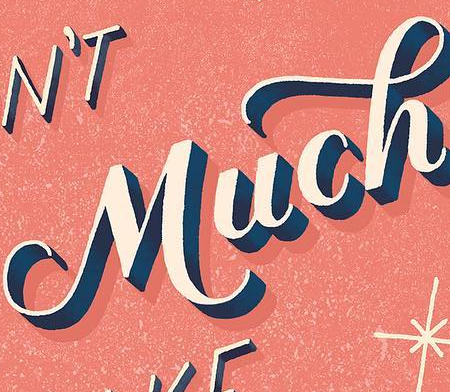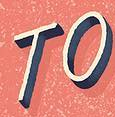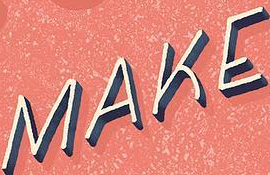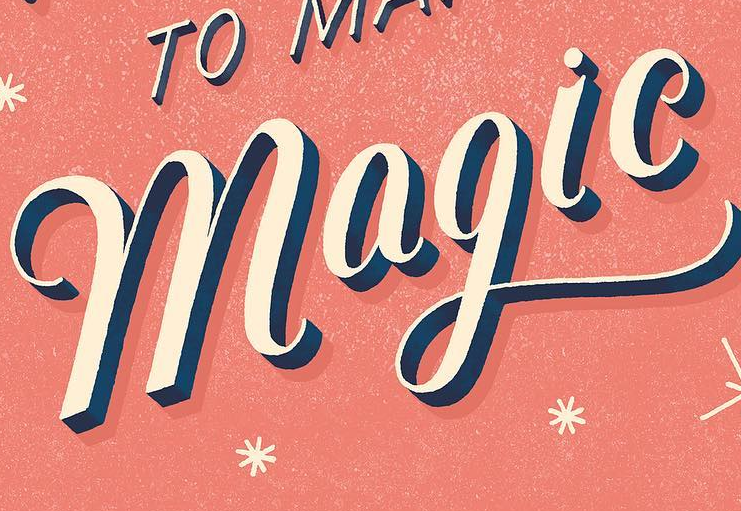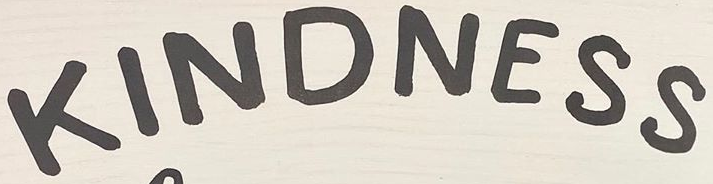What text is displayed in these images sequentially, separated by a semicolon? Much; TO; MAKE; magic; KINDNESS 